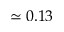Convert formula to latex. <formula><loc_0><loc_0><loc_500><loc_500>\simeq 0 . 1 3</formula> 